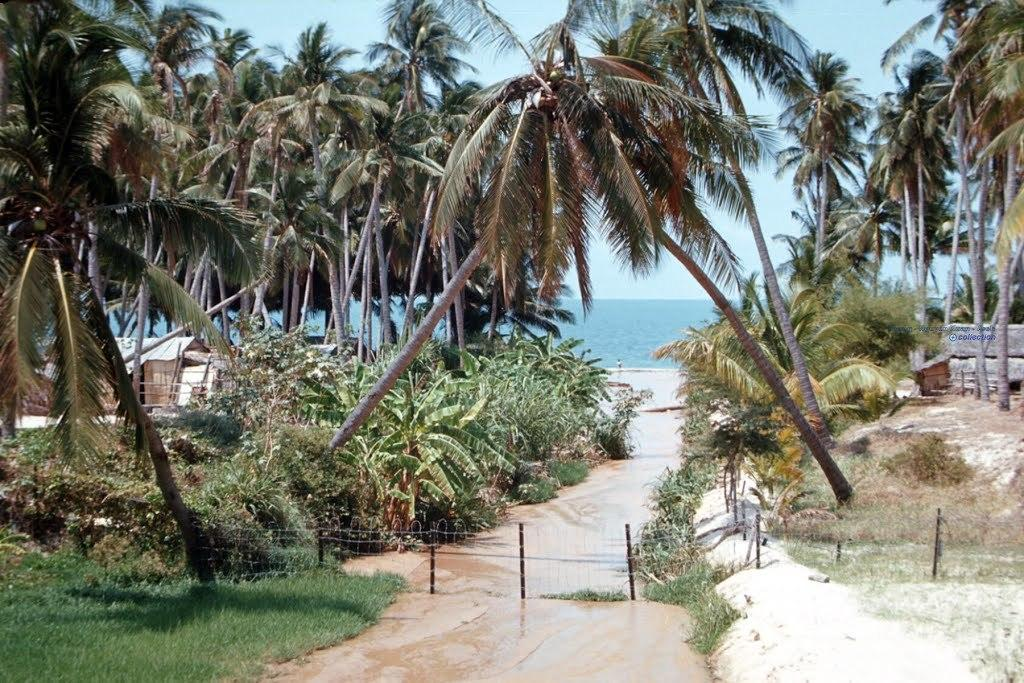What type of vegetation is visible in the image? There are trees in the image. What material are the rods in the image made of? The rods in the image are made of metal. What can be seen in the image besides the trees and metal rods? There is water visible in the image. What type of structure is present in the image? There is a small house in the image. How does the comparison between the trees and the floor in the image look like? There is no floor present in the image, as it features trees, metal rods, water, and a small house. How many drops of water can be seen falling from the sky in the image? There is no water falling from the sky in the image; it only shows water visible in the image. 